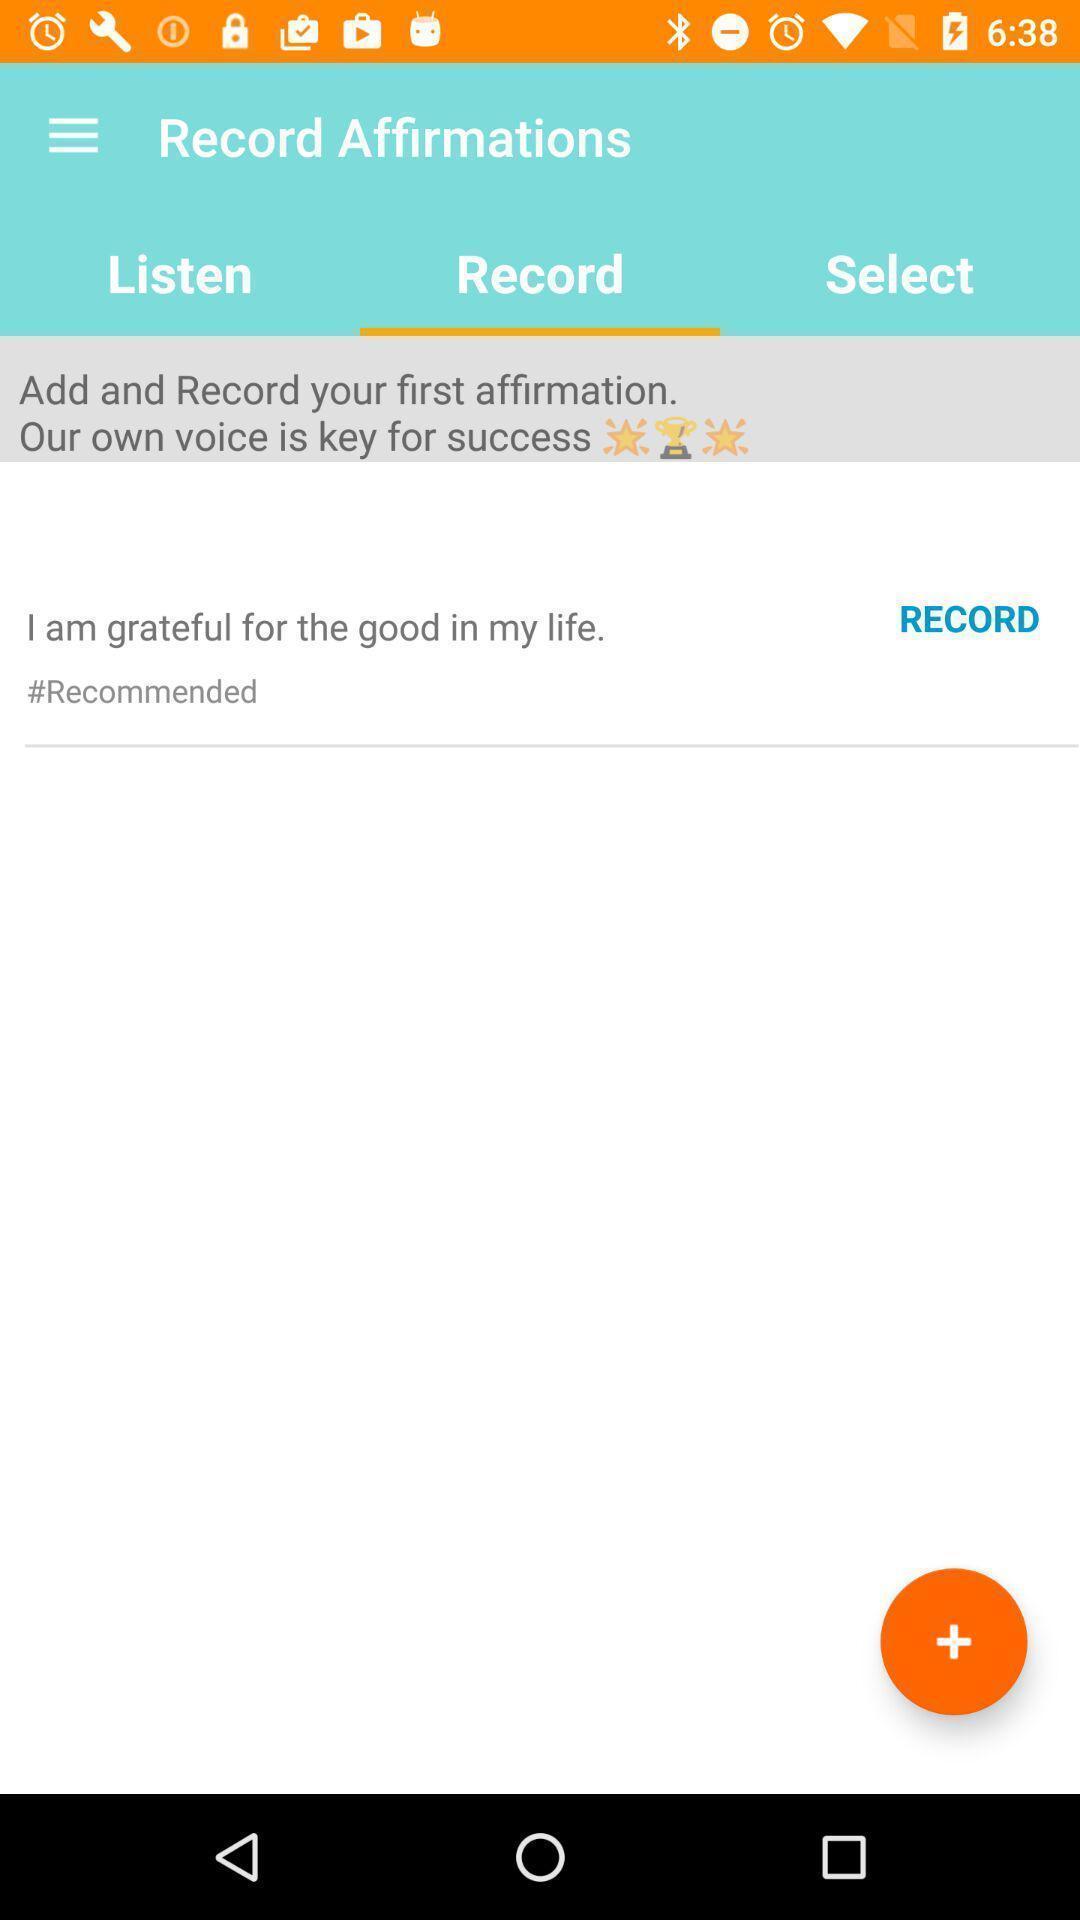Describe the content in this image. Page that displaying record option. 